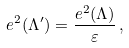Convert formula to latex. <formula><loc_0><loc_0><loc_500><loc_500>e ^ { 2 } ( \Lambda ^ { \prime } ) = \frac { e ^ { 2 } ( \Lambda ) } { \varepsilon } \, ,</formula> 